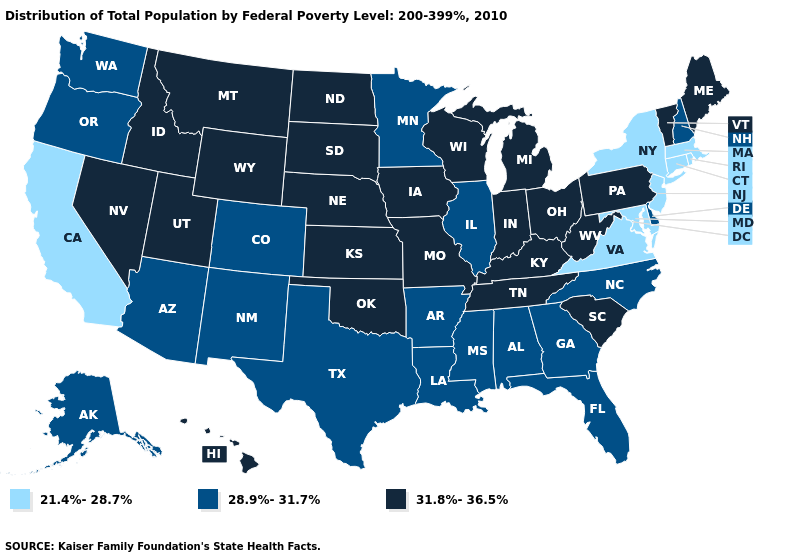Does Oregon have the highest value in the West?
Concise answer only. No. What is the lowest value in states that border Louisiana?
Short answer required. 28.9%-31.7%. Which states hav the highest value in the South?
Keep it brief. Kentucky, Oklahoma, South Carolina, Tennessee, West Virginia. What is the lowest value in the MidWest?
Give a very brief answer. 28.9%-31.7%. What is the value of Texas?
Quick response, please. 28.9%-31.7%. Which states have the lowest value in the USA?
Give a very brief answer. California, Connecticut, Maryland, Massachusetts, New Jersey, New York, Rhode Island, Virginia. What is the value of Washington?
Quick response, please. 28.9%-31.7%. What is the value of Wisconsin?
Keep it brief. 31.8%-36.5%. Which states have the lowest value in the USA?
Give a very brief answer. California, Connecticut, Maryland, Massachusetts, New Jersey, New York, Rhode Island, Virginia. What is the value of Michigan?
Be succinct. 31.8%-36.5%. What is the lowest value in states that border Alabama?
Write a very short answer. 28.9%-31.7%. What is the highest value in the USA?
Answer briefly. 31.8%-36.5%. What is the value of Arkansas?
Answer briefly. 28.9%-31.7%. Which states have the lowest value in the USA?
Give a very brief answer. California, Connecticut, Maryland, Massachusetts, New Jersey, New York, Rhode Island, Virginia. 